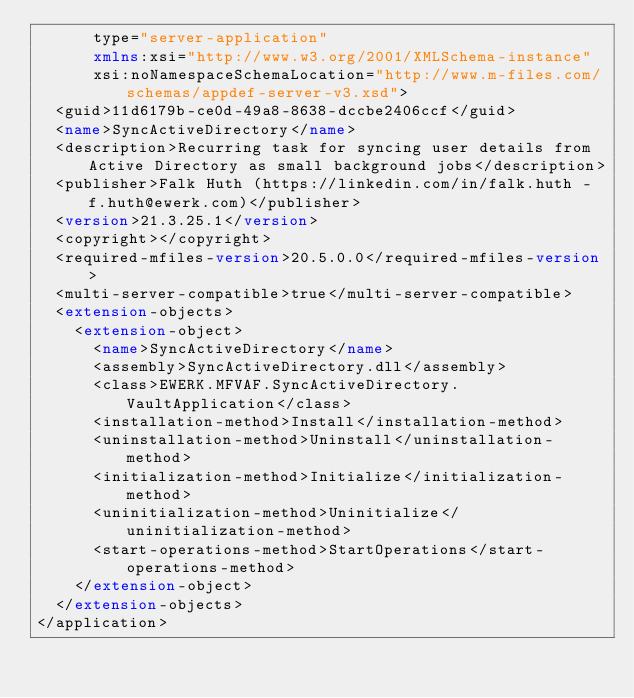<code> <loc_0><loc_0><loc_500><loc_500><_XML_>      type="server-application"
      xmlns:xsi="http://www.w3.org/2001/XMLSchema-instance"
      xsi:noNamespaceSchemaLocation="http://www.m-files.com/schemas/appdef-server-v3.xsd">
  <guid>11d6179b-ce0d-49a8-8638-dccbe2406ccf</guid>
  <name>SyncActiveDirectory</name>
  <description>Recurring task for syncing user details from Active Directory as small background jobs</description>
  <publisher>Falk Huth (https://linkedin.com/in/falk.huth - f.huth@ewerk.com)</publisher>
  <version>21.3.25.1</version>
  <copyright></copyright>
  <required-mfiles-version>20.5.0.0</required-mfiles-version>
  <multi-server-compatible>true</multi-server-compatible>
  <extension-objects>
    <extension-object>
      <name>SyncActiveDirectory</name>
      <assembly>SyncActiveDirectory.dll</assembly>
      <class>EWERK.MFVAF.SyncActiveDirectory.VaultApplication</class>
      <installation-method>Install</installation-method>
      <uninstallation-method>Uninstall</uninstallation-method>
      <initialization-method>Initialize</initialization-method>
      <uninitialization-method>Uninitialize</uninitialization-method>
      <start-operations-method>StartOperations</start-operations-method>
    </extension-object>
  </extension-objects>
</application>
</code> 